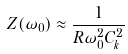<formula> <loc_0><loc_0><loc_500><loc_500>Z ( \omega _ { 0 } ) \approx \frac { 1 } { R \omega _ { 0 } ^ { 2 } C _ { k } ^ { 2 } }</formula> 